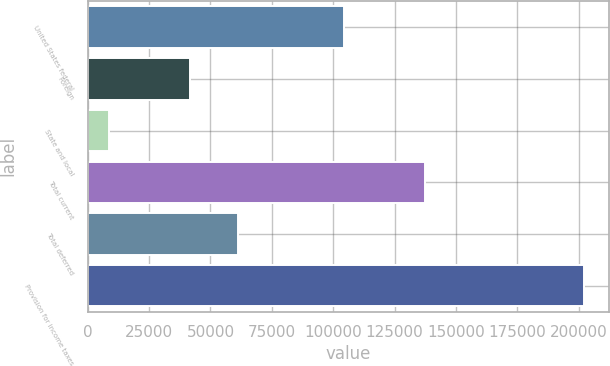<chart> <loc_0><loc_0><loc_500><loc_500><bar_chart><fcel>United States federal<fcel>Foreign<fcel>State and local<fcel>Total current<fcel>Total deferred<fcel>Provision for income taxes<nl><fcel>104587<fcel>41724<fcel>8769<fcel>137542<fcel>61085.4<fcel>202383<nl></chart> 